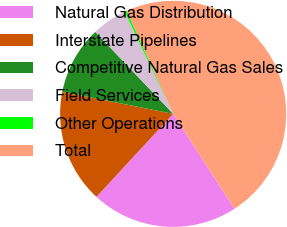Convert chart to OTSL. <chart><loc_0><loc_0><loc_500><loc_500><pie_chart><fcel>Natural Gas Distribution<fcel>Interstate Pipelines<fcel>Competitive Natural Gas Sales<fcel>Field Services<fcel>Other Operations<fcel>Total<nl><fcel>20.99%<fcel>16.26%<fcel>9.77%<fcel>5.04%<fcel>0.31%<fcel>47.63%<nl></chart> 